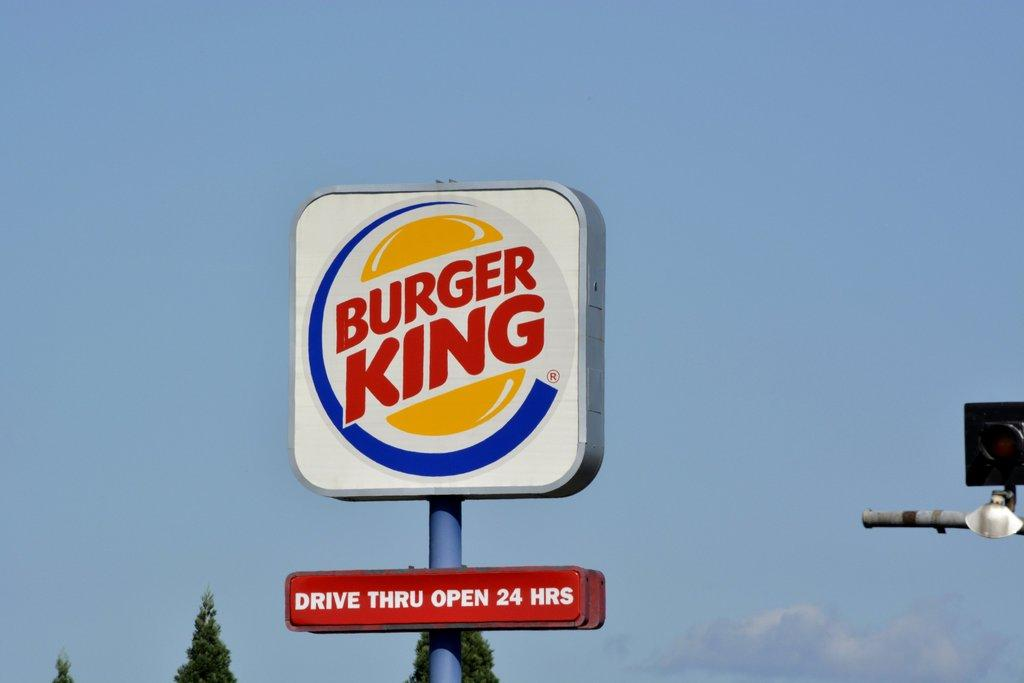Provide a one-sentence caption for the provided image. A burger king sign that says drive thru open 24 hours. 